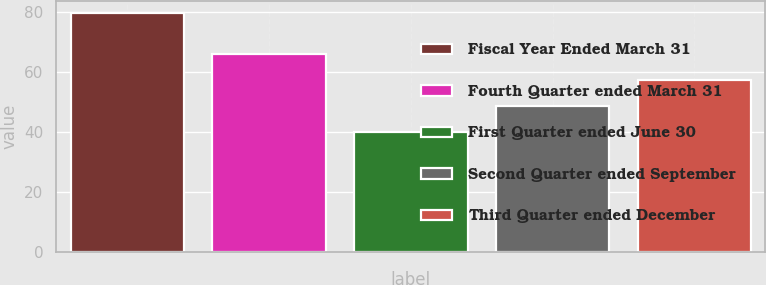<chart> <loc_0><loc_0><loc_500><loc_500><bar_chart><fcel>Fiscal Year Ended March 31<fcel>Fourth Quarter ended March 31<fcel>First Quarter ended June 30<fcel>Second Quarter ended September<fcel>Third Quarter ended December<nl><fcel>79.77<fcel>66.12<fcel>40.17<fcel>48.82<fcel>57.47<nl></chart> 